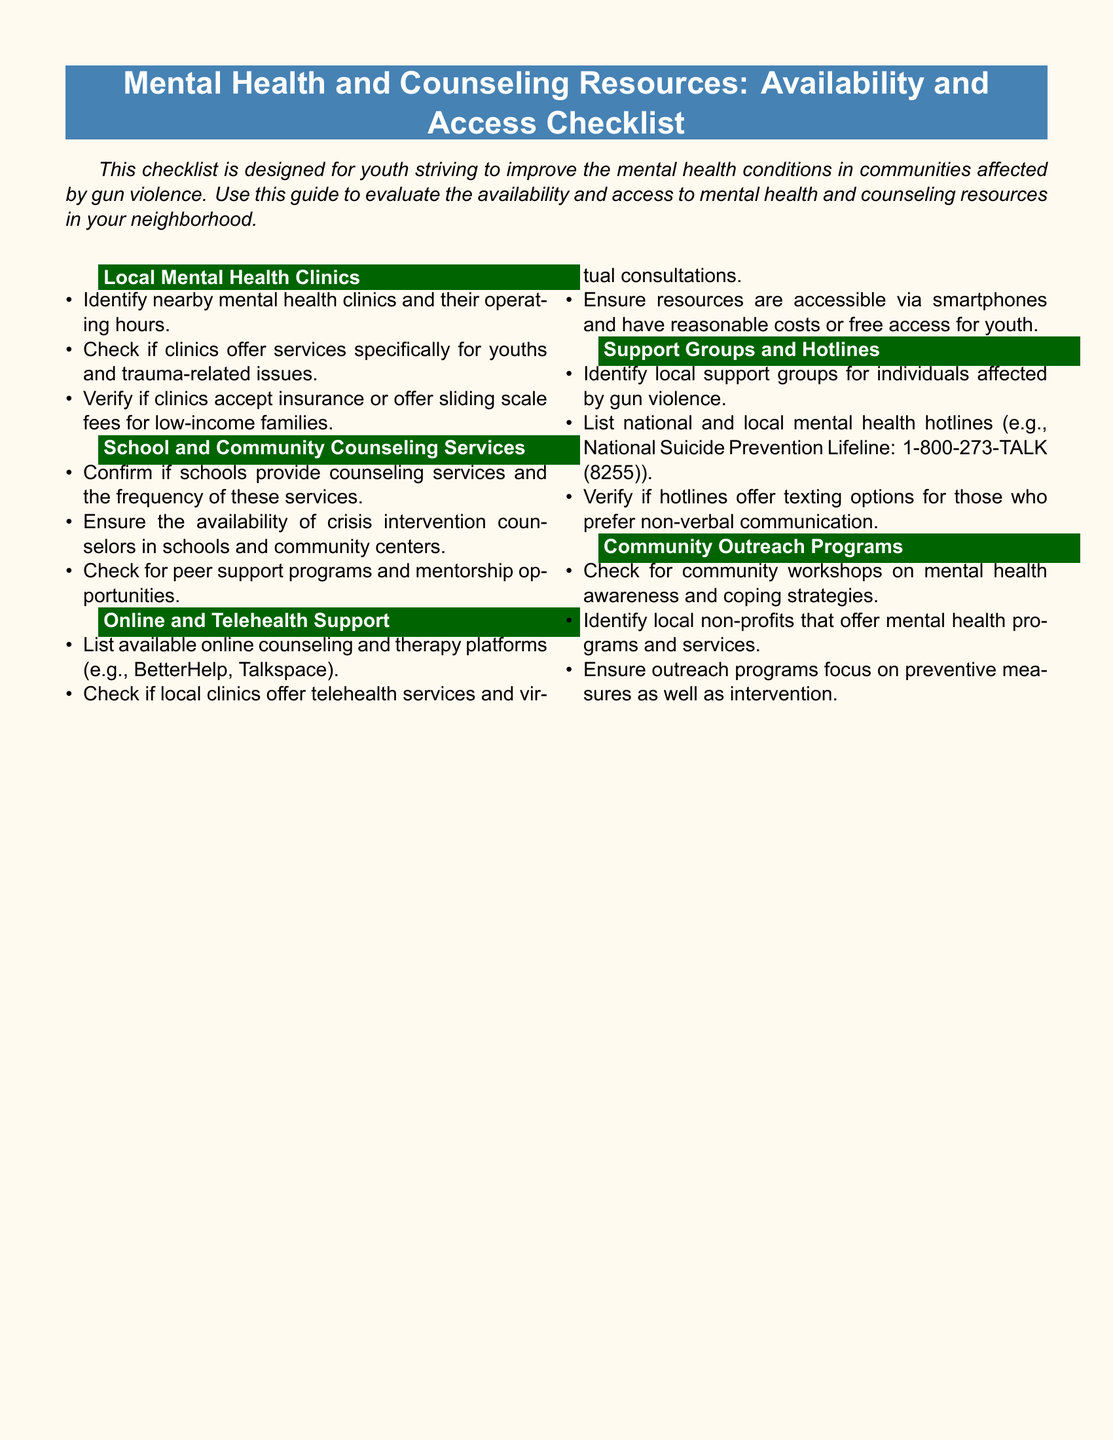What are the types of clinics listed? The document mentions "Local Mental Health Clinics" as a section, indicating that it focuses on specific types of clinics.
Answer: Local Mental Health Clinics What should you check regarding operating hours? The checklist suggests identifying nearby mental health clinics and their operating hours, emphasizing the need for specific details.
Answer: Operating hours Which resources support online counseling? The checklist lists "Online and Telehealth Support" as a section, addressing resources that provide remote counseling services.
Answer: Online counseling platforms What is mentioned as a communication option for hotlines? The document states that hotlines should verify if they offer texting options for communication, reflecting modern accessibility needs.
Answer: Texting options What is the purpose of community workshops mentioned? The document indicates that community workshops focus on mental health awareness and coping strategies, providing education and support.
Answer: Mental health awareness and coping strategies 